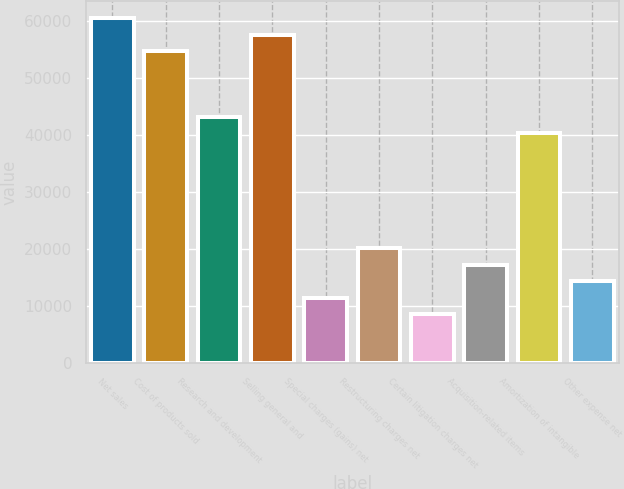Convert chart. <chart><loc_0><loc_0><loc_500><loc_500><bar_chart><fcel>Net sales<fcel>Cost of products sold<fcel>Research and development<fcel>Selling general and<fcel>Special charges (gains) net<fcel>Restructuring charges net<fcel>Certain litigation charges net<fcel>Acquisition-related items<fcel>Amortization of intangible<fcel>Other expense net<nl><fcel>60547.7<fcel>54781.4<fcel>43248.8<fcel>57664.5<fcel>11534.1<fcel>20183.6<fcel>8650.97<fcel>17300.4<fcel>40365.6<fcel>14417.3<nl></chart> 